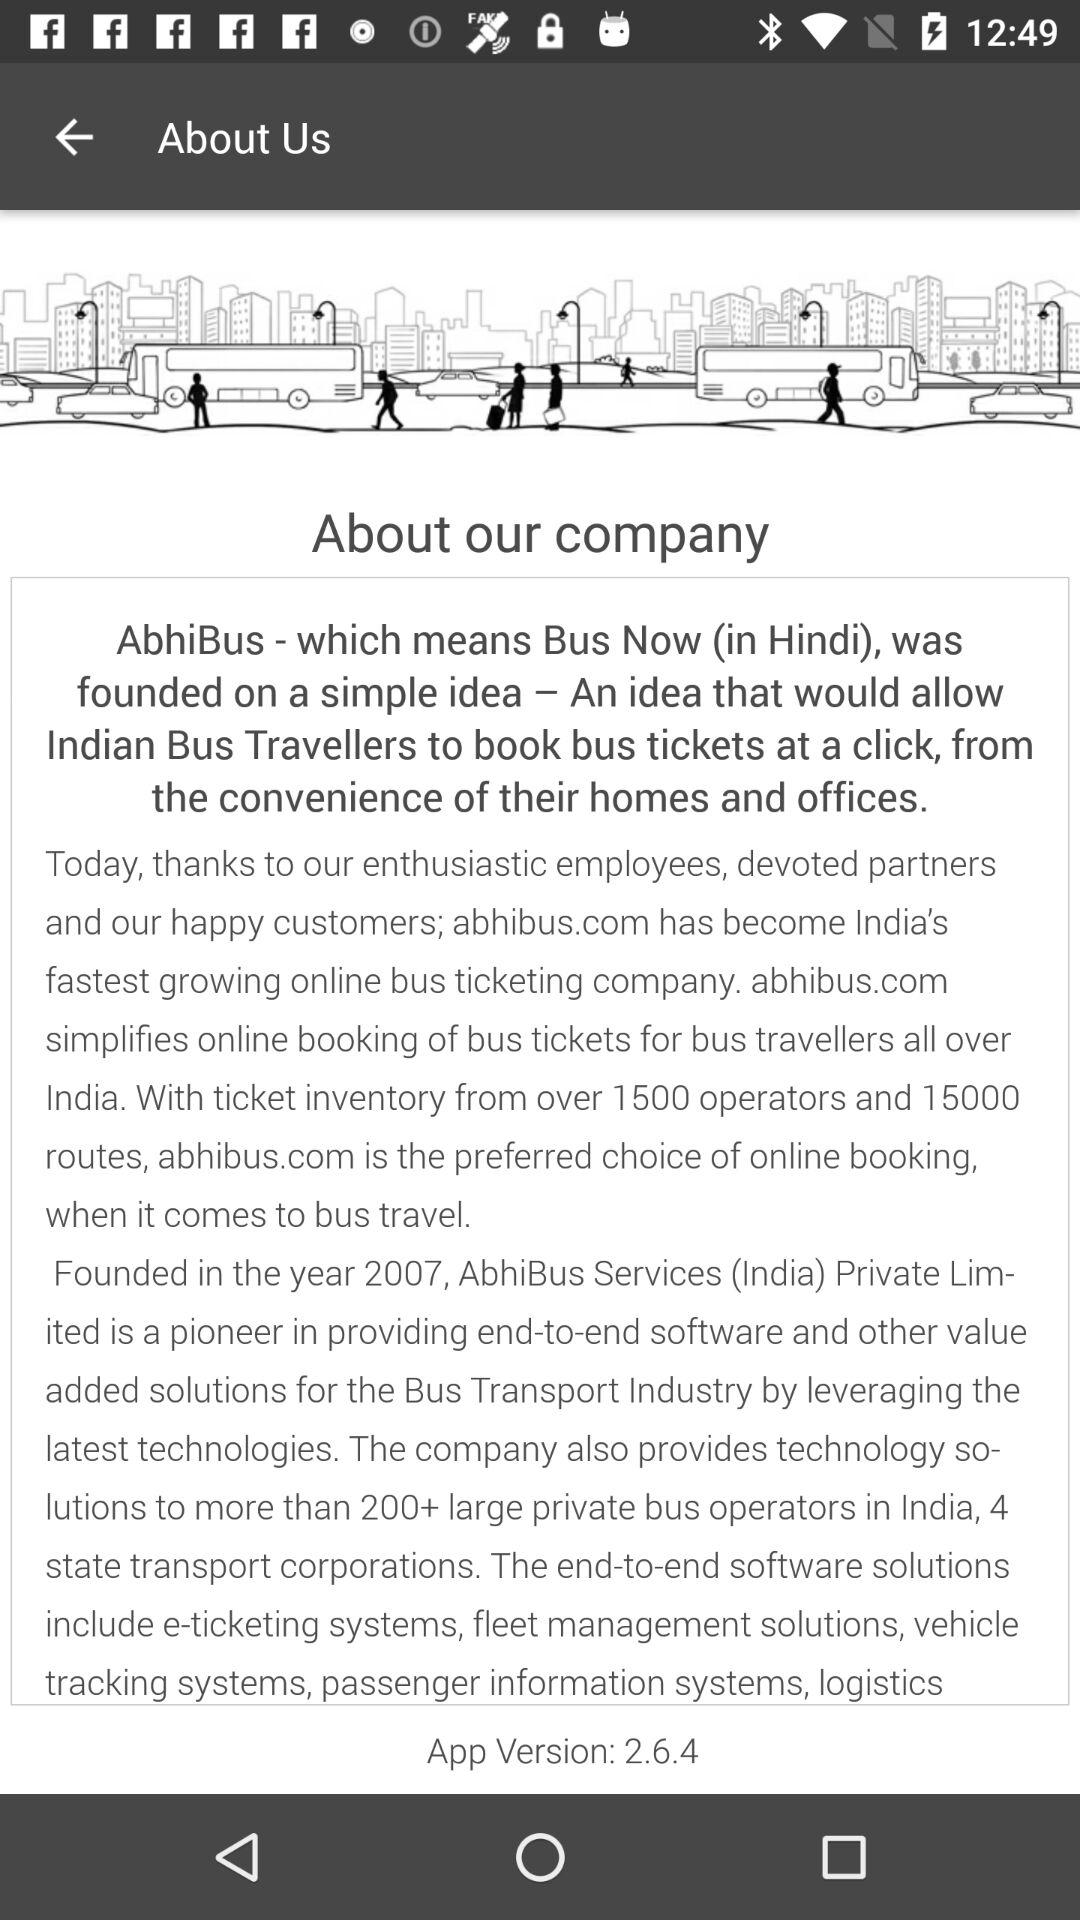When was "AbhiBus" founded? "AbhiBus" was founded in 2007. 